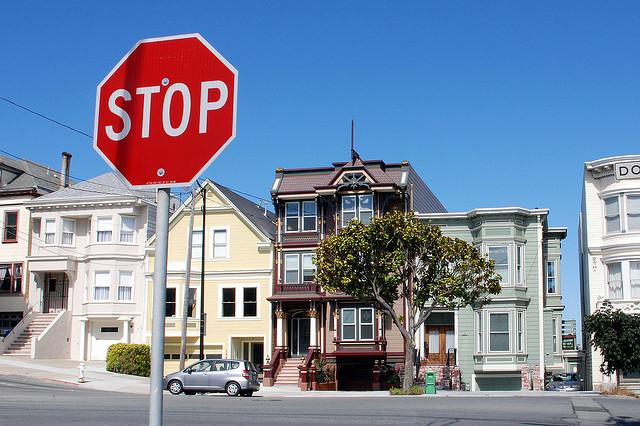Are these houses all the same style?
Concise answer only. No. Is there a street light?
Be succinct. No. What road sign is pictured?
Answer briefly. Stop. What is in front of the house?
Quick response, please. Tree. 